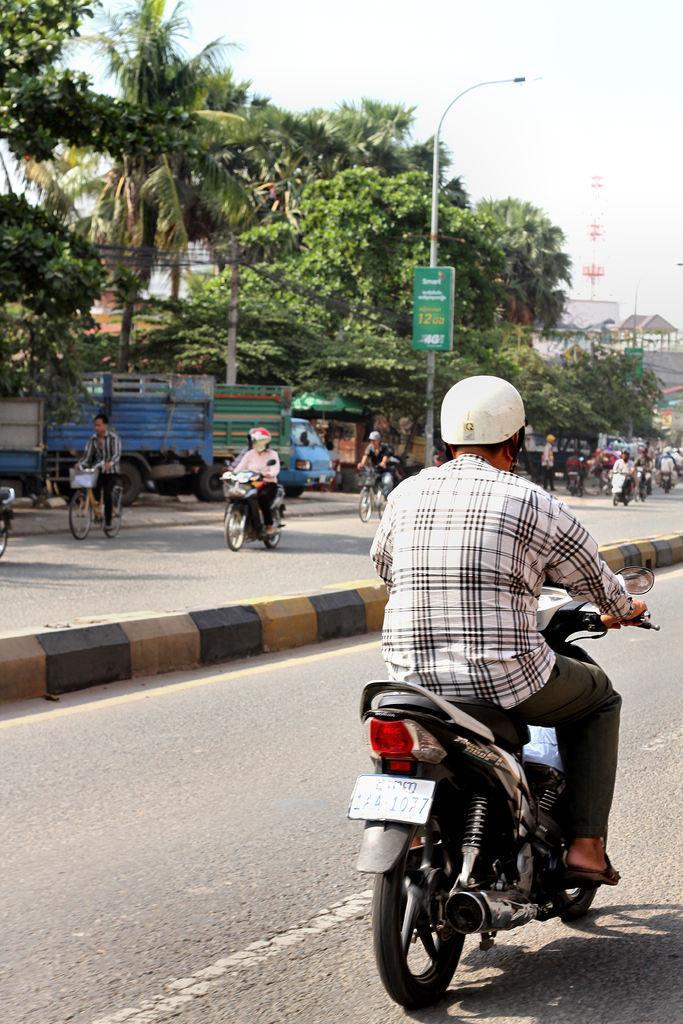Describe this image in one or two sentences. A person wearing a helmet is riding a motorcycle on a road. On the other side there are many people are riding motorcycles and cycles. There is a pole with light. On the pole there is a name board. In the background there are trees, also there is an electric pole, building and many other people are over there. 